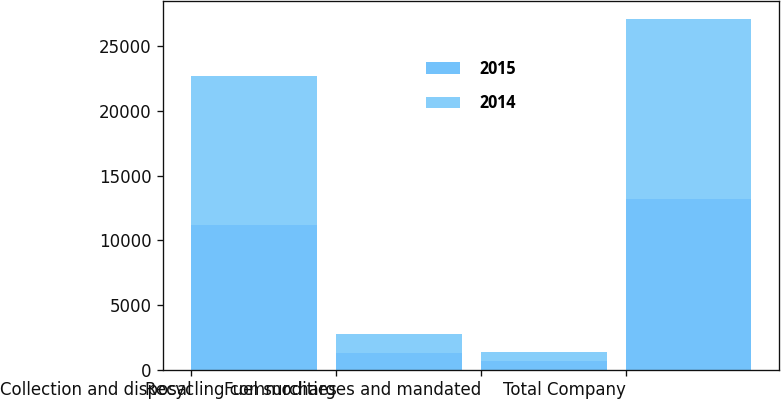<chart> <loc_0><loc_0><loc_500><loc_500><stacked_bar_chart><ecel><fcel>Collection and disposal<fcel>Recycling commodities<fcel>Fuel surcharges and mandated<fcel>Total Company<nl><fcel>2015<fcel>11214<fcel>1331<fcel>689<fcel>13234<nl><fcel>2014<fcel>11512<fcel>1431<fcel>684<fcel>13893<nl></chart> 